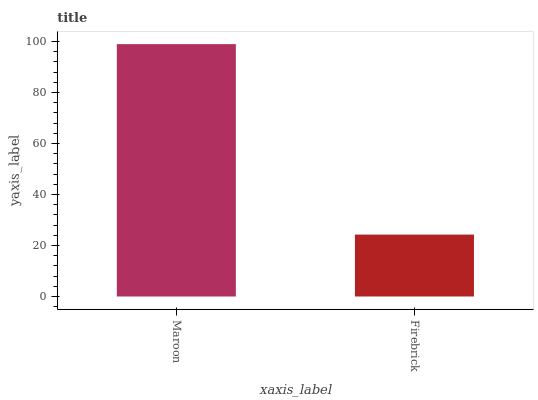Is Firebrick the minimum?
Answer yes or no. Yes. Is Maroon the maximum?
Answer yes or no. Yes. Is Firebrick the maximum?
Answer yes or no. No. Is Maroon greater than Firebrick?
Answer yes or no. Yes. Is Firebrick less than Maroon?
Answer yes or no. Yes. Is Firebrick greater than Maroon?
Answer yes or no. No. Is Maroon less than Firebrick?
Answer yes or no. No. Is Maroon the high median?
Answer yes or no. Yes. Is Firebrick the low median?
Answer yes or no. Yes. Is Firebrick the high median?
Answer yes or no. No. Is Maroon the low median?
Answer yes or no. No. 